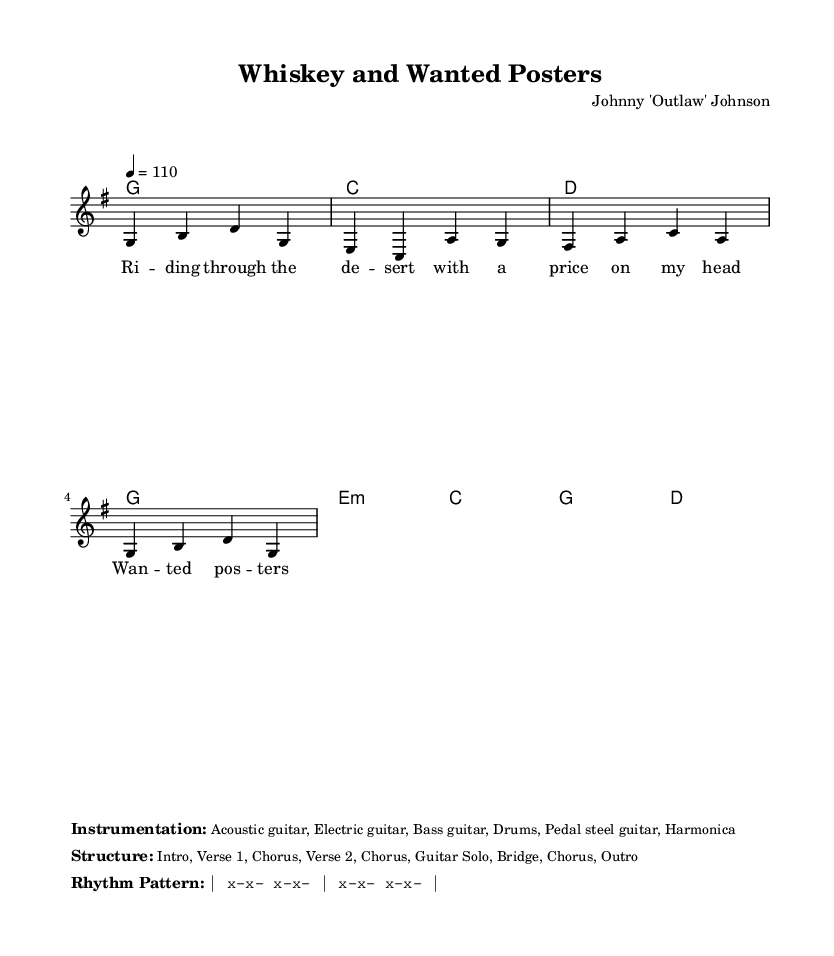What is the key signature of this music? The key signature shown is G major, which has one sharp (F#).
Answer: G major What is the time signature of the piece? The time signature indicated is 4/4, meaning there are four beats in each measure and the quarter note gets one beat.
Answer: 4/4 What is the tempo marking for the piece? The tempo marking indicates a speed of 110 beats per minute, which sets the pace at which the music should be played.
Answer: 110 How many verses are present in the song structure? The structure outlines two verses (Verse 1 and Verse 2) as part of the overall arrangement.
Answer: 2 What instrumentation is used in this composition? The instrumentation comprises acoustic guitar, electric guitar, bass guitar, drums, pedal steel guitar, and harmonica, indicating a rich country rock sound.
Answer: Acoustic guitar, Electric guitar, Bass guitar, Drums, Pedal steel guitar, Harmonica What theme is introduced in Verse 1? The theme revolves around a narrative of a character with a price on their head, highlighting elements of outlaw country storytelling.
Answer: Wanted posters 